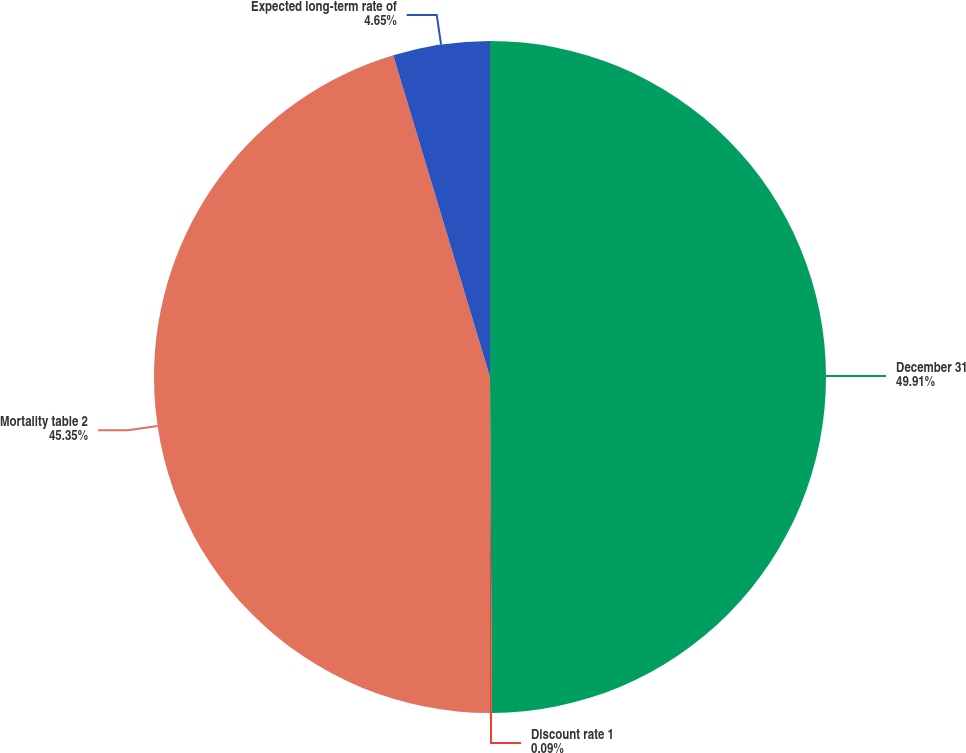Convert chart to OTSL. <chart><loc_0><loc_0><loc_500><loc_500><pie_chart><fcel>December 31<fcel>Discount rate 1<fcel>Mortality table 2<fcel>Expected long-term rate of<nl><fcel>49.91%<fcel>0.09%<fcel>45.35%<fcel>4.65%<nl></chart> 